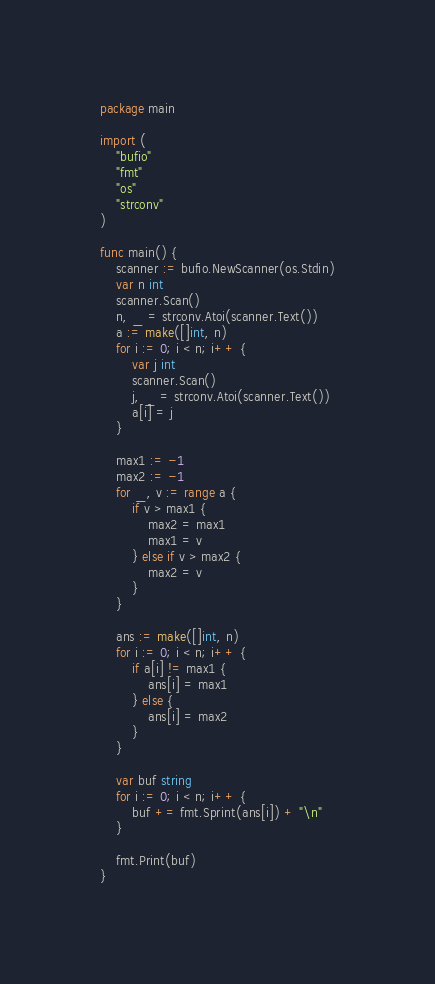<code> <loc_0><loc_0><loc_500><loc_500><_Go_>package main

import (
	"bufio"
	"fmt"
	"os"
	"strconv"
)

func main() {
	scanner := bufio.NewScanner(os.Stdin)
	var n int
	scanner.Scan()
	n, _ = strconv.Atoi(scanner.Text())
	a := make([]int, n)
	for i := 0; i < n; i++ {
		var j int
		scanner.Scan()
		j, _ = strconv.Atoi(scanner.Text())
		a[i] = j
	}

	max1 := -1
	max2 := -1
	for _, v := range a {
		if v > max1 {
			max2 = max1
			max1 = v
		} else if v > max2 {
			max2 = v
		}
	}

	ans := make([]int, n)
	for i := 0; i < n; i++ {
		if a[i] != max1 {
			ans[i] = max1
		} else {
			ans[i] = max2
		}
	}

	var buf string
	for i := 0; i < n; i++ {
		buf += fmt.Sprint(ans[i]) + "\n"
	}

	fmt.Print(buf)
}</code> 